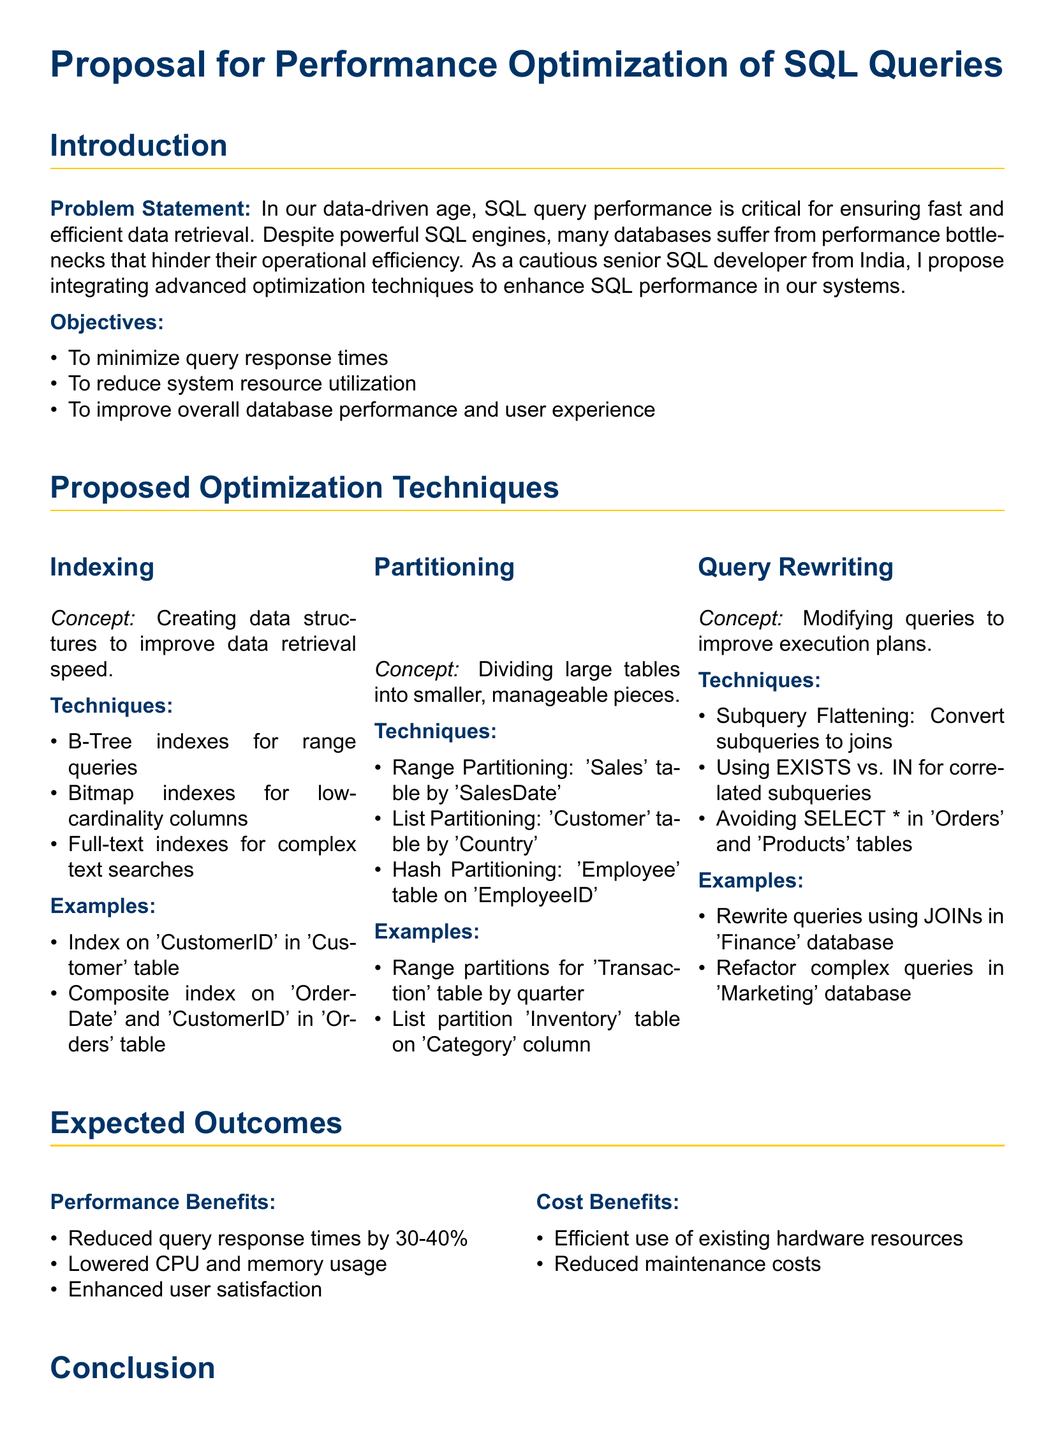what is the main title of the proposal? The main title is explicitly mentioned at the start of the document as "Proposal for Performance Optimization of SQL Queries."
Answer: Proposal for Performance Optimization of SQL Queries what are the three proposed optimization techniques? The three proposed optimization techniques are listed under the "Proposed Optimization Techniques" section.
Answer: Indexing, Partitioning, and Query Rewriting how much can query response times be reduced by, according to the expected outcomes? The expected outcomes list a specific range for the reduction of query response times.
Answer: 30-40% what is one of the objectives stated in the document? Objectives are presented in a list format, detailing what the proposal aims to achieve.
Answer: To minimize query response times which indexing technique is mentioned for complex text searches? The document provides specific indexing techniques under the "Indexing" subsection that include a mention for complex text searches.
Answer: Full-text indexes what is the concept of Partitioning explained as? The document provides a brief description of what Partitioning involves in the context of database management.
Answer: Dividing large tables into smaller, manageable pieces what is the expected cost benefit related to hardware resources? The expected cost benefits are discussed under the "Cost Benefits" section, indicating how the proposal optimizes resources.
Answer: Efficient use of existing hardware resources what document type is this proposal categorized as? The document identifies itself clearly at the beginning and throughout in its structure and purpose.
Answer: Proposal 